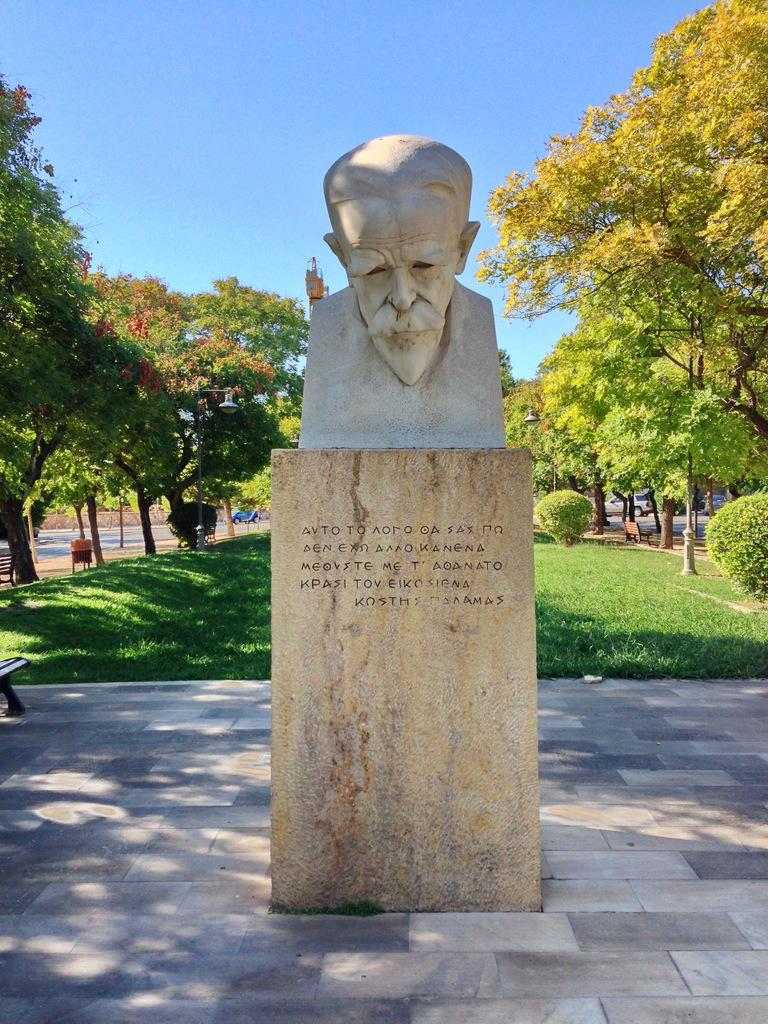What is the main subject in the image? There is a statue in the image. Can you describe the color of the statue? The statue is in cream color. What can be seen in the background of the image? There are trees and the sky visible in the background of the image. What is the color of the trees? The trees are green. What is the color of the sky? The sky is blue. What type of food is being prepared by the family in the image? There is no family or food preparation present in the image; it features a statue and the surrounding environment. 